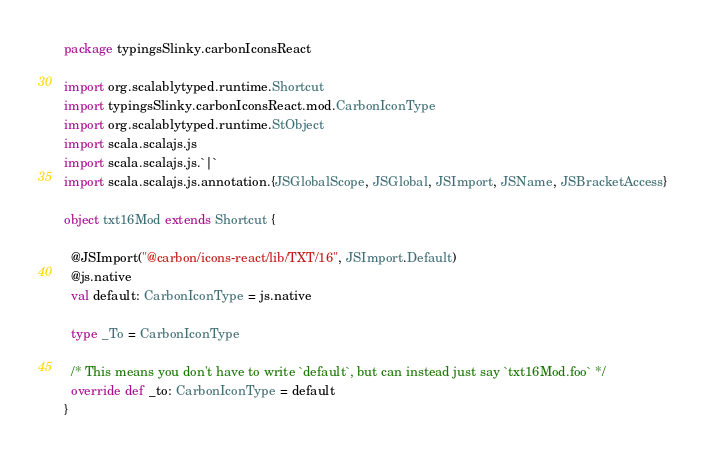<code> <loc_0><loc_0><loc_500><loc_500><_Scala_>package typingsSlinky.carbonIconsReact

import org.scalablytyped.runtime.Shortcut
import typingsSlinky.carbonIconsReact.mod.CarbonIconType
import org.scalablytyped.runtime.StObject
import scala.scalajs.js
import scala.scalajs.js.`|`
import scala.scalajs.js.annotation.{JSGlobalScope, JSGlobal, JSImport, JSName, JSBracketAccess}

object txt16Mod extends Shortcut {
  
  @JSImport("@carbon/icons-react/lib/TXT/16", JSImport.Default)
  @js.native
  val default: CarbonIconType = js.native
  
  type _To = CarbonIconType
  
  /* This means you don't have to write `default`, but can instead just say `txt16Mod.foo` */
  override def _to: CarbonIconType = default
}
</code> 